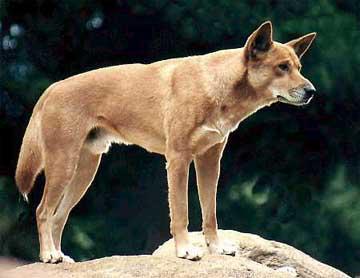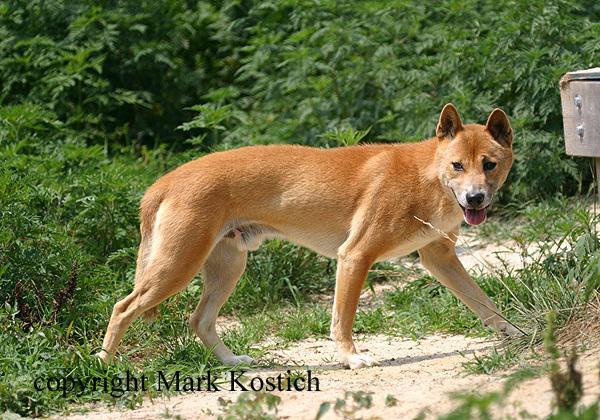The first image is the image on the left, the second image is the image on the right. Given the left and right images, does the statement "The dog in the left image stands on a rock, body in profile turned rightward." hold true? Answer yes or no. Yes. The first image is the image on the left, the second image is the image on the right. Assess this claim about the two images: "There are two dogs, and neither of them is looking to the left.". Correct or not? Answer yes or no. Yes. 